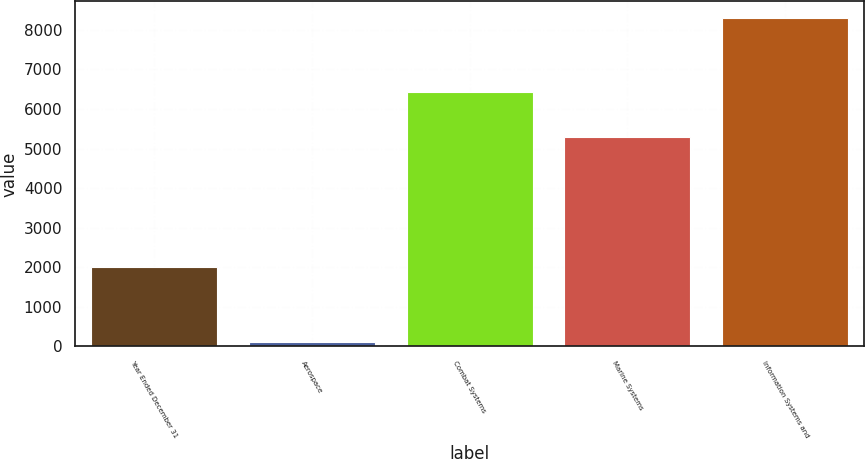Convert chart. <chart><loc_0><loc_0><loc_500><loc_500><bar_chart><fcel>Year Ended December 31<fcel>Aerospace<fcel>Combat Systems<fcel>Marine Systems<fcel>Information Systems and<nl><fcel>2008<fcel>125<fcel>6424<fcel>5290<fcel>8307<nl></chart> 